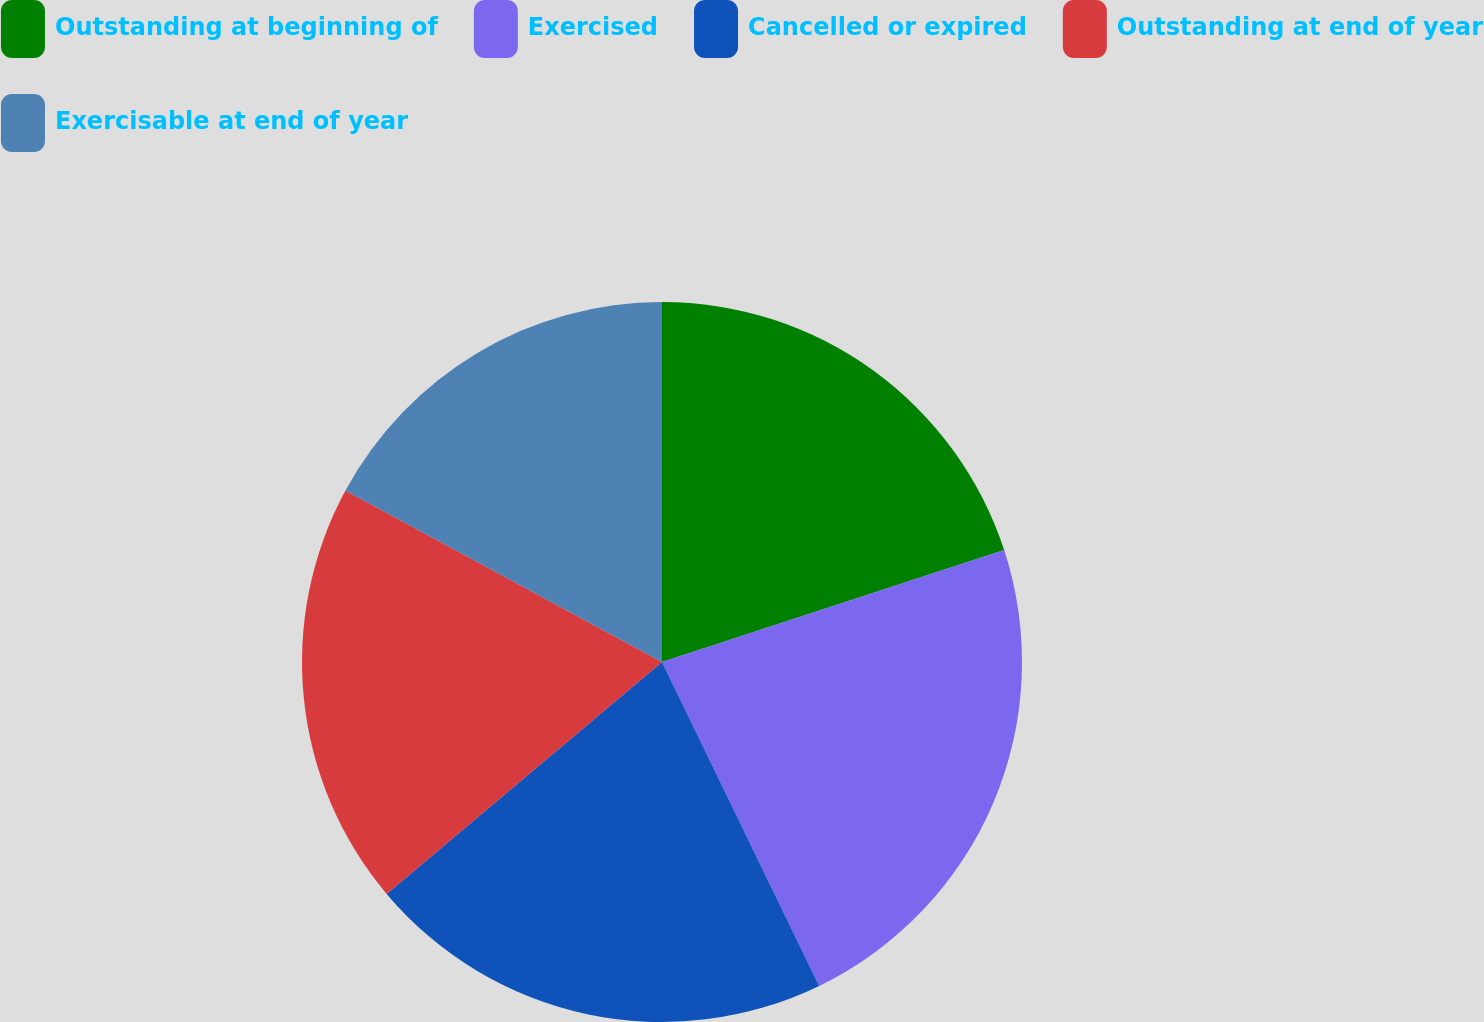Convert chart. <chart><loc_0><loc_0><loc_500><loc_500><pie_chart><fcel>Outstanding at beginning of<fcel>Exercised<fcel>Cancelled or expired<fcel>Outstanding at end of year<fcel>Exercisable at end of year<nl><fcel>19.97%<fcel>22.84%<fcel>21.05%<fcel>19.04%<fcel>17.1%<nl></chart> 